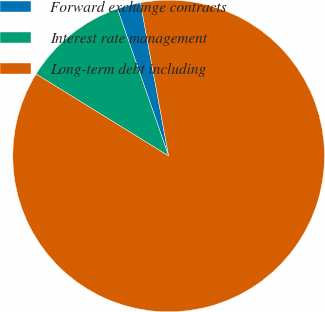<chart> <loc_0><loc_0><loc_500><loc_500><pie_chart><fcel>Forward exchange contracts<fcel>Interest rate management<fcel>Long-term debt including<nl><fcel>2.43%<fcel>10.86%<fcel>86.72%<nl></chart> 